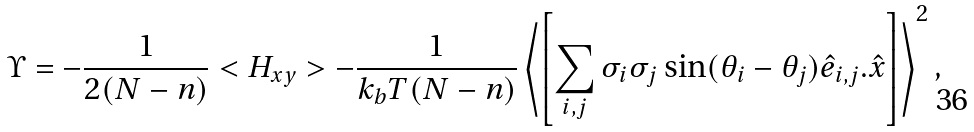Convert formula to latex. <formula><loc_0><loc_0><loc_500><loc_500>\Upsilon = - \frac { 1 } { 2 ( N - n ) } < H _ { x y } > - \frac { 1 } { k _ { b } T ( N - n ) } \left < \left [ \sum _ { i , j } \sigma _ { i } \sigma _ { j } \sin ( \theta _ { i } - \theta _ { j } ) \hat { e } _ { i , j } . \hat { x } \right ] \right > ^ { 2 } ,</formula> 